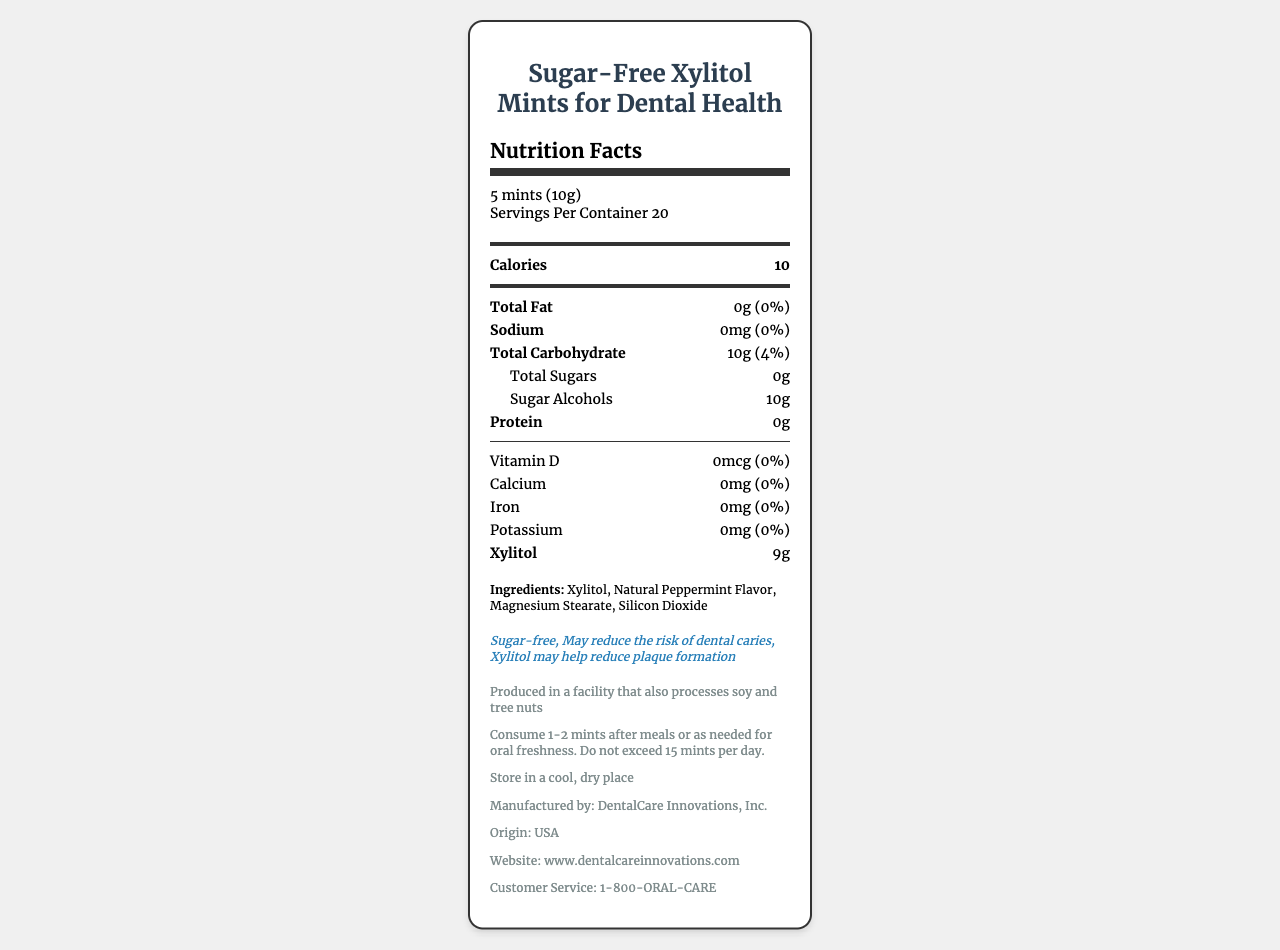what is the serving size? The serving size is clearly listed at the beginning of the document as "5 mints (10g)".
Answer: 5 mints (10g) how many calories are there per serving? The number of calories per serving is indicated right after the serving size information.
Answer: 10 calories how many grams of sugar alcohols are in each serving? Under the nutrient section, it specifies that there are 10 grams of sugar alcohols per serving.
Answer: 10g how many servings are in the container? The document lists "Servings Per Container" as 20.
Answer: 20 how much xylitol is in each serving? The amount of xylitol per serving is stated under the nutrient section as 9 grams.
Answer: 9g what allergens might be present in the product? The allergen information indicates that the facility processes soy and tree nuts.
Answer: Soy and tree nuts what is the main purpose of this product according to the health claims? A. To provide dietary fiber B. To reduce dental caries C. To supplement vitamins The health claims mention that the product may reduce the risk of dental caries and help reduce plaque formation.
Answer: B which country is this product manufactured in? A. USA B. Canada C. Germany D. China The product is stated to be manufactured in the USA under the additional information section.
Answer: A does the product contain any protein? The nutrient section indicates that the product contains 0 grams of protein.
Answer: No is this product sugar-free? One of the key health claims of the product is that it is "Sugar-free".
Answer: Yes how many grams of total sugars are in the product? The total sugars content is indicated as 0 grams under the nutrient section.
Answer: 0g can we determine the exact number of calories burned by consuming this product? The document provides nutritional information including calories per serving, but it does not provide information on calorie expenditure from consuming the product.
Answer: Not enough information please summarize the main content of the document. The document is a comprehensive guide on the nutritional content, benefits, and usage of the Sugar-Free Xylitol Mints, aimed at promoting dental health.
Answer: The document provides nutritional facts and additional information for a product called "Sugar-Free Xylitol Mints for Dental Health". It details serving size, number of servings, calorie count, and levels of various nutrients. The product claims to be sugar-free, might reduce the risk of dental caries, and may help reduce plaque formation. Ingredients, allergen information, usage instructions, storage guidelines, and manufacturer details are also provided. 